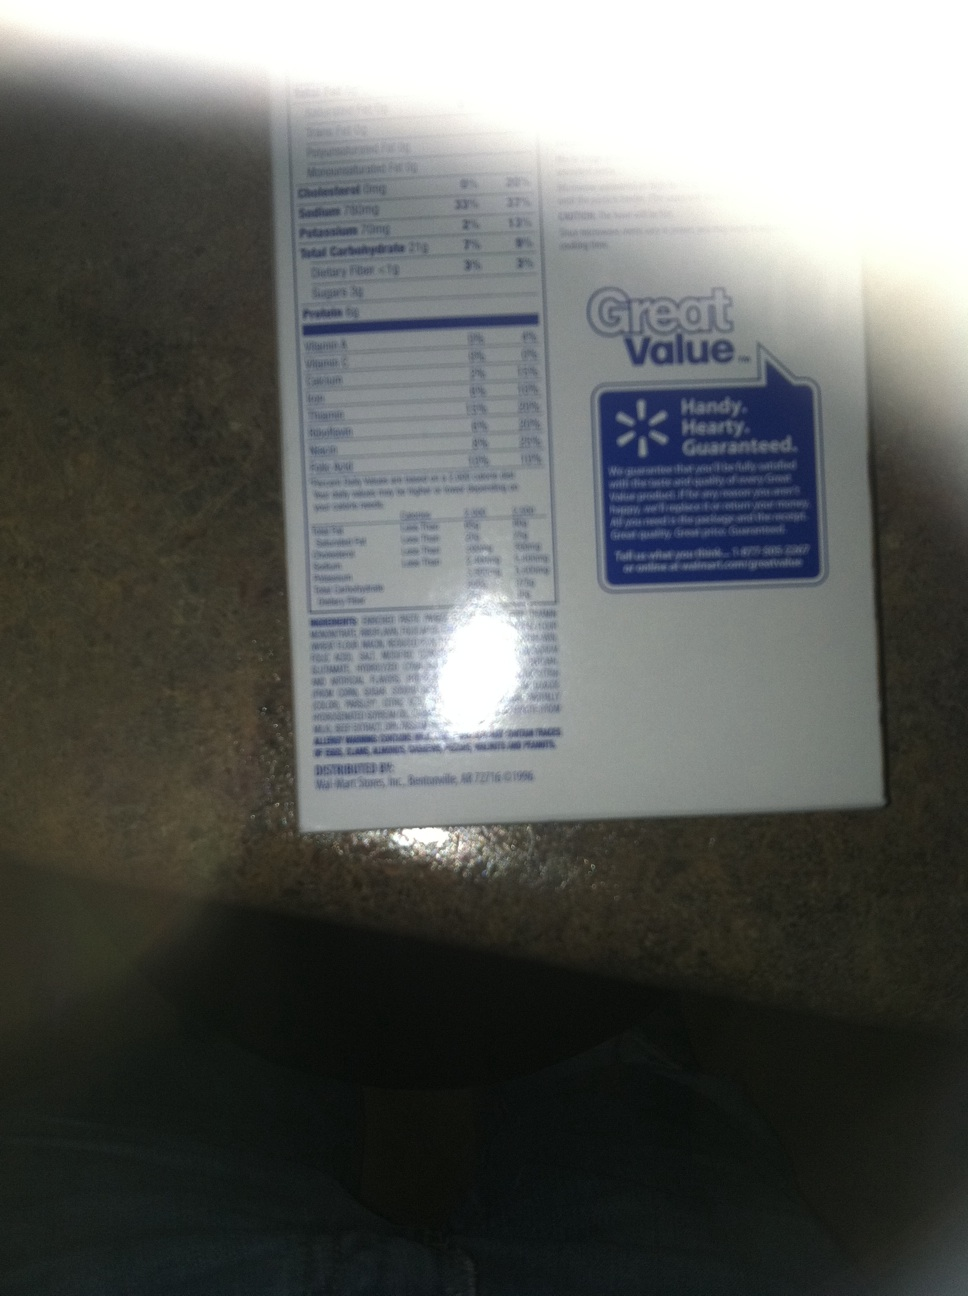Can you tell me more about the health information on this label? Certainly! The label lists nutrition facts including a serving size of 1 cookie (38g). It shows that each serving contains 170 calories, 3.5g of total fat, 3% of the daily value of cholesterol, and 10% of the daily sodium intake. Additionally, it details dietary fibers, sugars, and protein amounts, making it useful for managing dietary needs. 